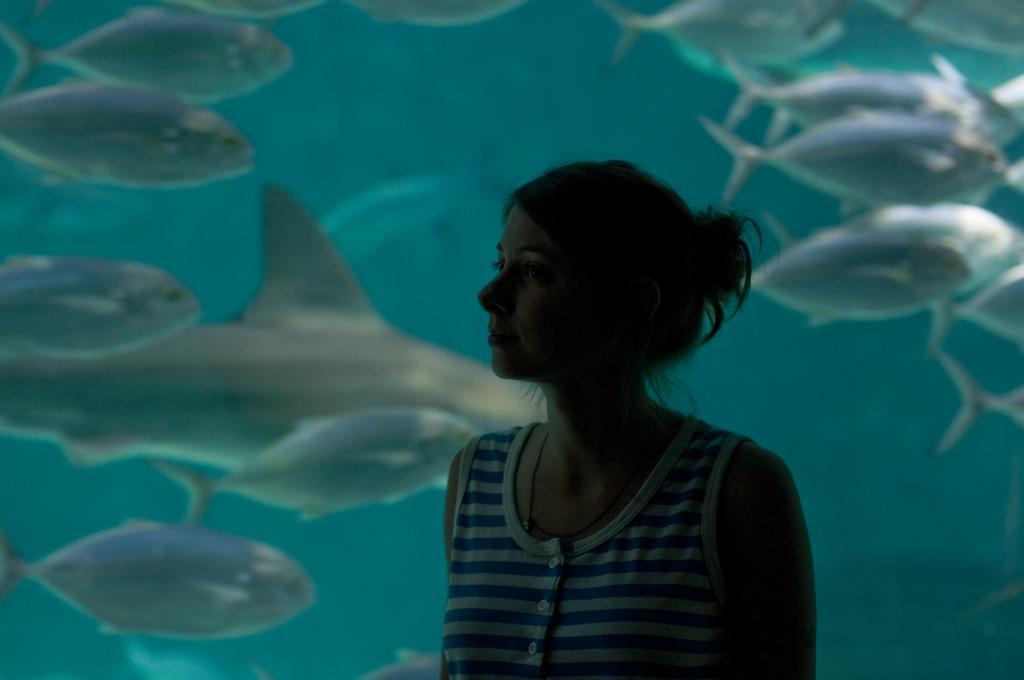Describe this image in one or two sentences. In this image I can see a woman and behind her I can see a huge fish-tank in which I can see few aquatic animals. 